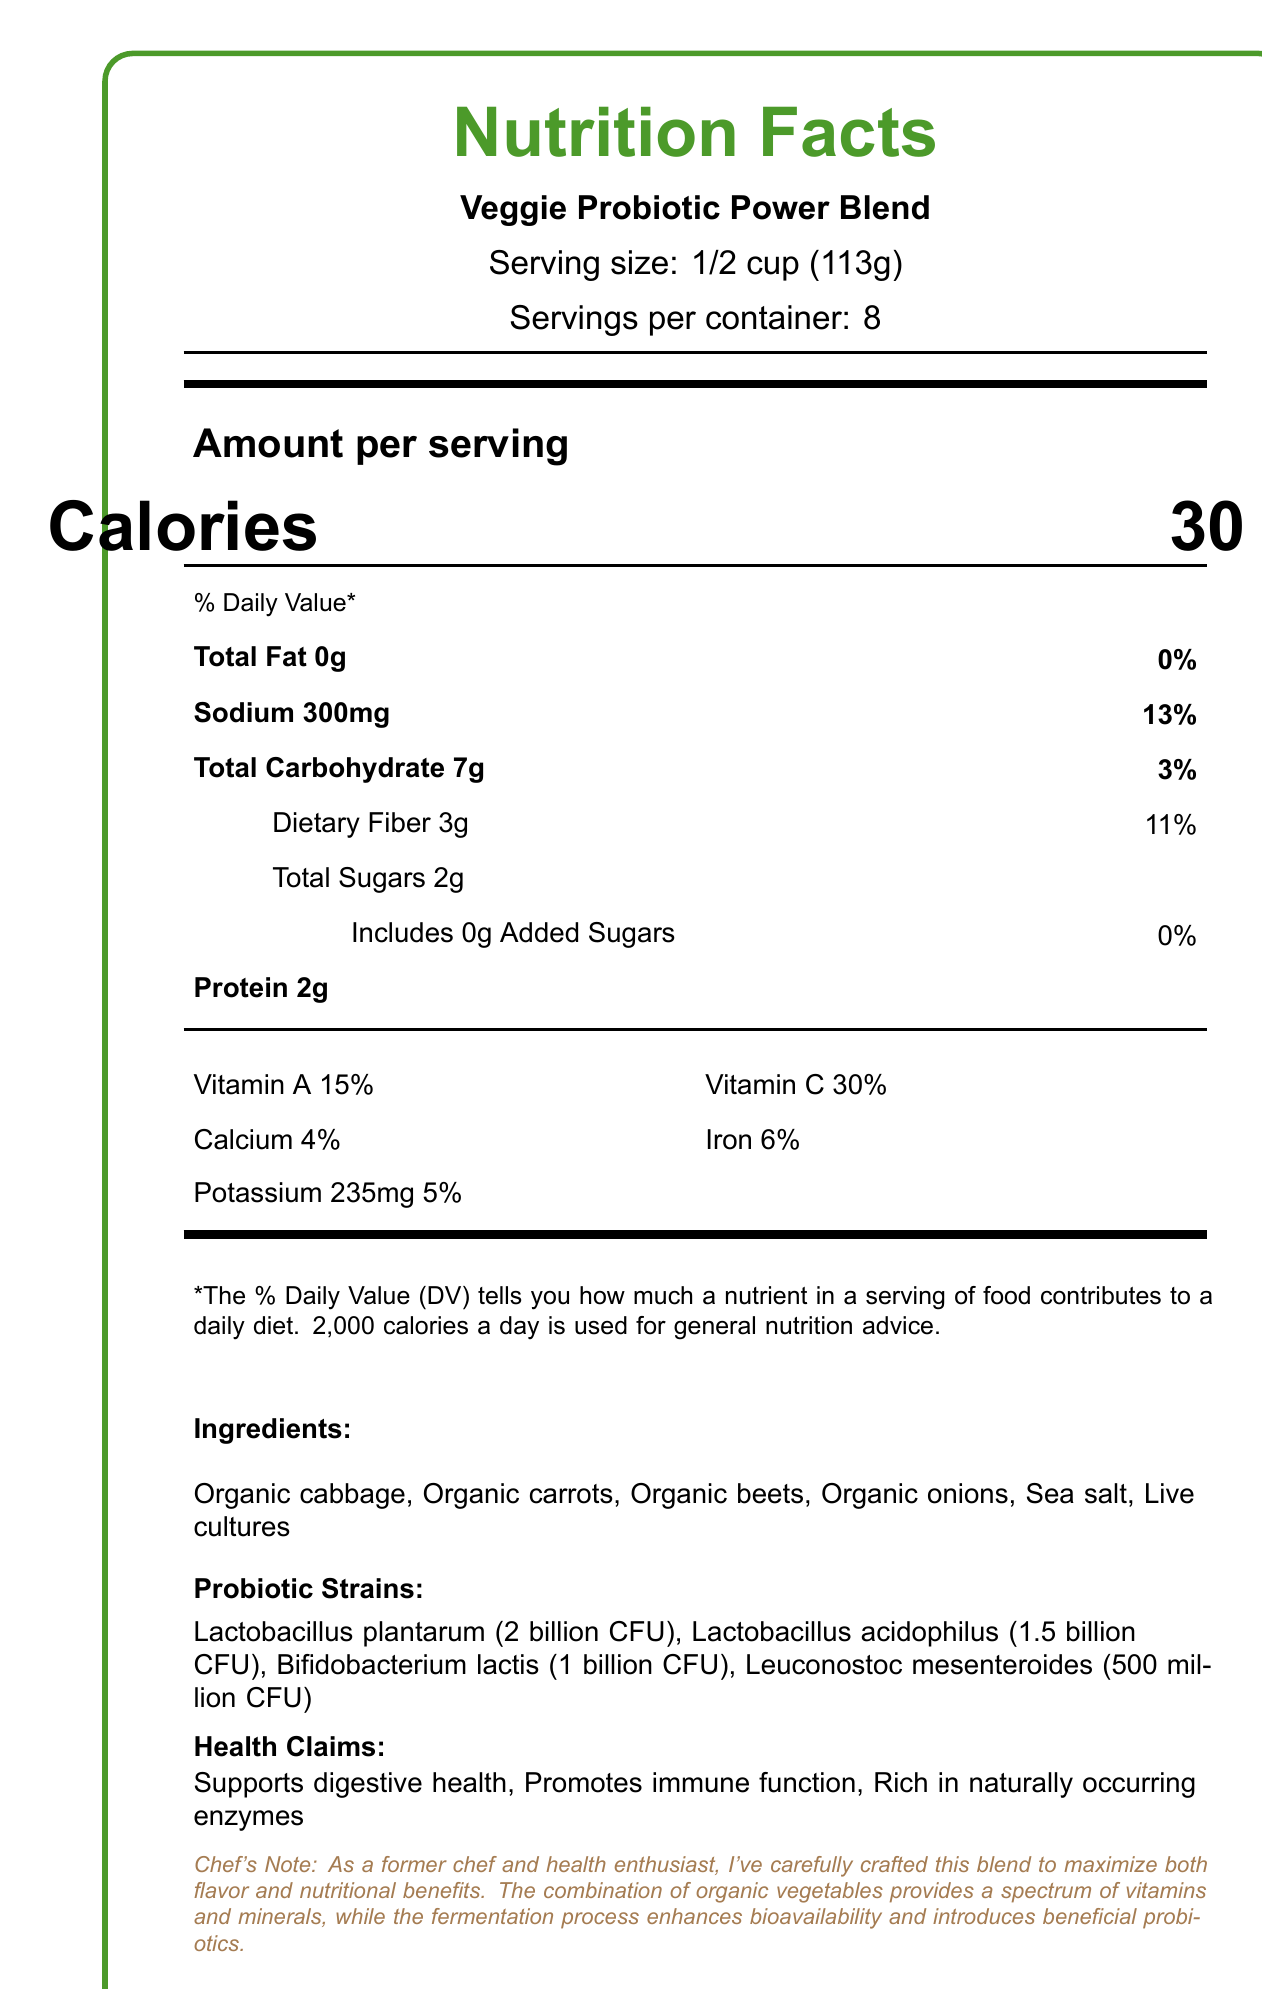what is the serving size? The serving size is clearly stated as "1/2 cup (113g)" under the product name and serving information.
Answer: 1/2 cup (113g) how many calories are in one serving? The document lists "Calories 30" under "Amount per serving."
Answer: 30 how much sodium is in one serving, and what percentage of the daily value (DV) does it represent? The amount of sodium per serving is given as 300mg, with a daily value percentage of 13%.
Answer: 300mg, 13% what are the four primary probiotic strains, and what are their colony-forming unit (CFU) counts? The probiotic strains and their CFU counts are listed under "Probiotic Strains."
Answer: Lactobacillus plantarum (2 billion CFU), Lactobacillus acidophilus (1.5 billion CFU), Bifidobacterium lactis (1 billion CFU), Leuconostoc mesenteroides (500 million CFU) what are the health claims associated with this product? The health claims are listed under the "Health Claims" section.
Answer: Supports digestive health, Promotes immune function, Rich in naturally occurring enzymes what percentage of the daily value for dietary fiber does one serving provide? The dietary fiber percentage is listed under the nutrient information as 11%.
Answer: 11% what is the total carbohydrate content per serving? The total carbohydrate content is listed as 7g under the nutrient information.
Answer: 7g how many servings are there per container? The document lists "Servings per container: 8" under the product name and serving information.
Answer: 8 what allergen information is provided for this product? The allergen information is provided at the end of the ingredients list.
Answer: Manufactured in a facility that processes tree nuts and soy what are the main ingredients in this blend? The main ingredients are listed under the "Ingredients" section.
Answer: Organic cabbage, Organic carrots, Organic beets, Organic onions, Sea salt, Live cultures which of the following vitamins is provided in the highest percentage of the daily value in one serving? A. Vitamin A B. Vitamin C C. Calcium D. Iron The percentages of the daily values for each vitamin are listed, with Vitamin C at 30%, which is the highest among the options.
Answer: B. Vitamin C how should the product be stored after opening? A. In a cool, dry place B. Keep refrigerated C. Store in a freezer D. Keep at room temperature The storage instructions indicate that the product should be refrigerated and consumed within 14 days of opening.
Answer: B. Keep refrigerated does this product contain any added sugars? The document lists "Includes 0g Added Sugars" under the total sugars information.
Answer: No are the vitamins and minerals percentages based on a 2000-calorie diet? The note at the bottom of the document states that the % Daily Value is based on a 2000-calorie diet.
Answer: Yes how does the fermentation process benefit the product according to the chef's note? The chef's note explains that fermentation enhances bioavailability and introduces beneficial probiotics.
Answer: Enhances bioavailability and introduces beneficial probiotics what is the suggested use of this product for a probiotic boost? Under "Serving Suggestions," one of the uses is to add it to salads for a probiotic boost.
Answer: Add to salads what kind of flavor can you expect from this product based on the ingredients? The document does not provide specific information on the flavor profile beyond mentioning "tangy."
Answer: Cannot be determined what is the main message of the document? The document provides a detailed description of the Veggie Probiotic Power Blend, including its nutritional information, ingredients, probiotic strains, health benefits, storage instructions, and the chef's insight on the blend's creation.
Answer: Description of Veggie Probiotic Power Blend with nutrition facts, ingredients, probiotic strains, health claims, storage instructions, and chef's note 